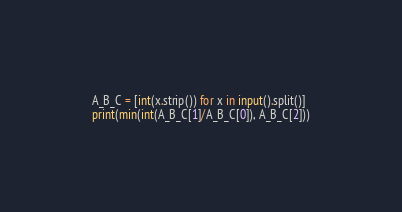<code> <loc_0><loc_0><loc_500><loc_500><_Python_>A_B_C = [int(x.strip()) for x in input().split()]
print(min(int(A_B_C[1]/A_B_C[0]), A_B_C[2]))</code> 